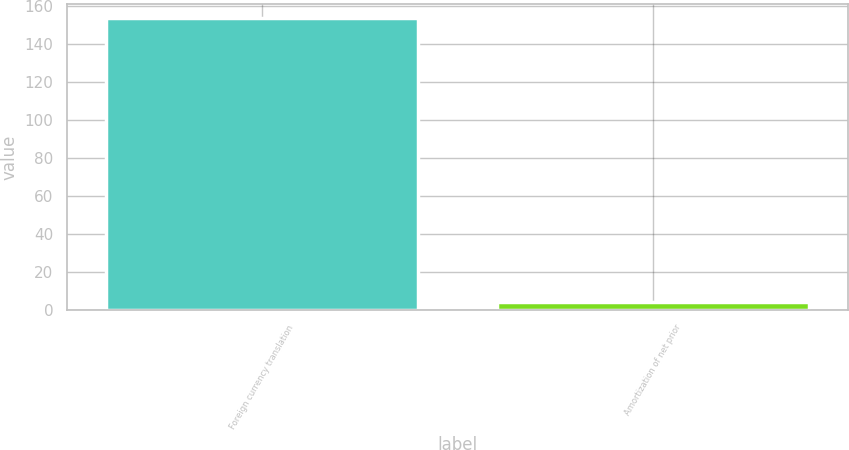Convert chart to OTSL. <chart><loc_0><loc_0><loc_500><loc_500><bar_chart><fcel>Foreign currency translation<fcel>Amortization of net prior<nl><fcel>153.5<fcel>4.3<nl></chart> 